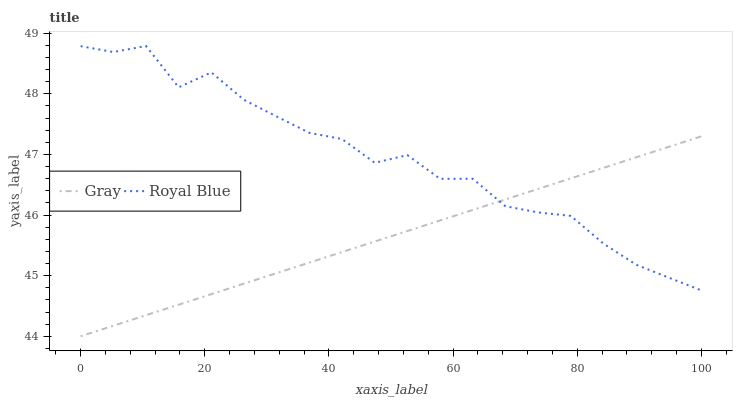Does Gray have the minimum area under the curve?
Answer yes or no. Yes. Does Royal Blue have the maximum area under the curve?
Answer yes or no. Yes. Does Royal Blue have the minimum area under the curve?
Answer yes or no. No. Is Gray the smoothest?
Answer yes or no. Yes. Is Royal Blue the roughest?
Answer yes or no. Yes. Is Royal Blue the smoothest?
Answer yes or no. No. Does Gray have the lowest value?
Answer yes or no. Yes. Does Royal Blue have the lowest value?
Answer yes or no. No. Does Royal Blue have the highest value?
Answer yes or no. Yes. Does Gray intersect Royal Blue?
Answer yes or no. Yes. Is Gray less than Royal Blue?
Answer yes or no. No. Is Gray greater than Royal Blue?
Answer yes or no. No. 